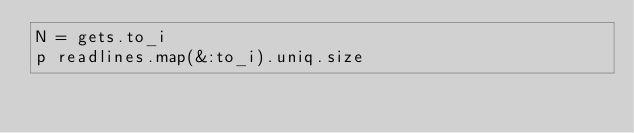Convert code to text. <code><loc_0><loc_0><loc_500><loc_500><_Ruby_>N = gets.to_i
p readlines.map(&:to_i).uniq.size</code> 